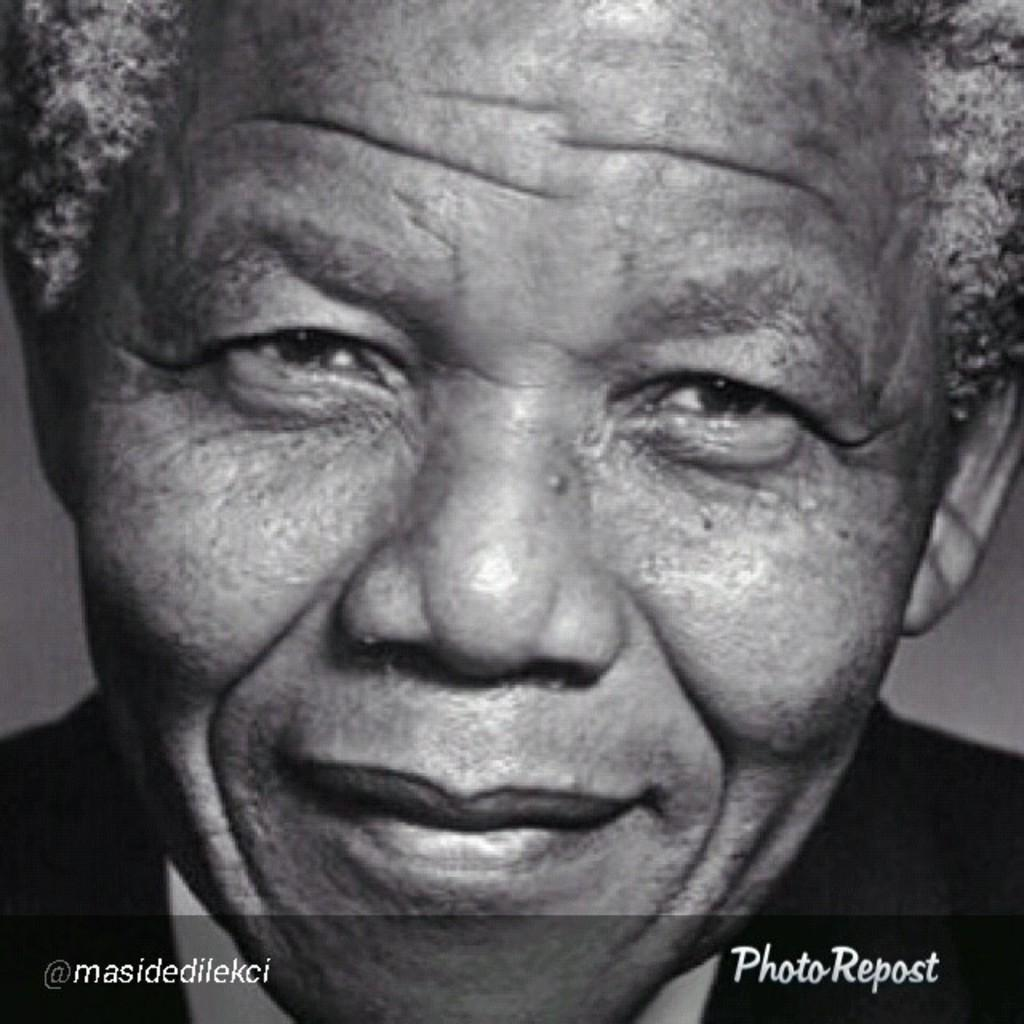What is the color scheme of the image? The image is black and white. Can you describe the person in the image? There is a person in the image, and they are smiling. Is there any text or marking at the bottom of the image? Yes, there is a watermark at the bottom of the image. What type of sweater is the person wearing in the image? There is no sweater visible in the image, as it is black and white and does not show any clothing details. 